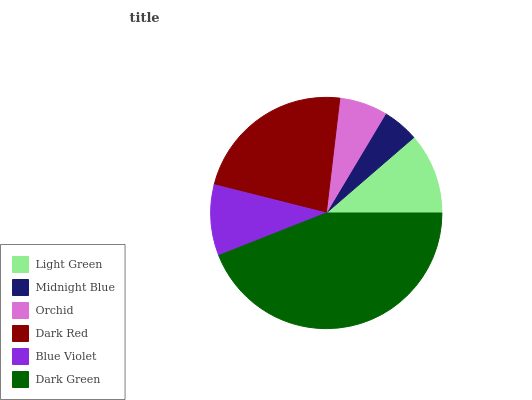Is Midnight Blue the minimum?
Answer yes or no. Yes. Is Dark Green the maximum?
Answer yes or no. Yes. Is Orchid the minimum?
Answer yes or no. No. Is Orchid the maximum?
Answer yes or no. No. Is Orchid greater than Midnight Blue?
Answer yes or no. Yes. Is Midnight Blue less than Orchid?
Answer yes or no. Yes. Is Midnight Blue greater than Orchid?
Answer yes or no. No. Is Orchid less than Midnight Blue?
Answer yes or no. No. Is Light Green the high median?
Answer yes or no. Yes. Is Blue Violet the low median?
Answer yes or no. Yes. Is Dark Green the high median?
Answer yes or no. No. Is Midnight Blue the low median?
Answer yes or no. No. 